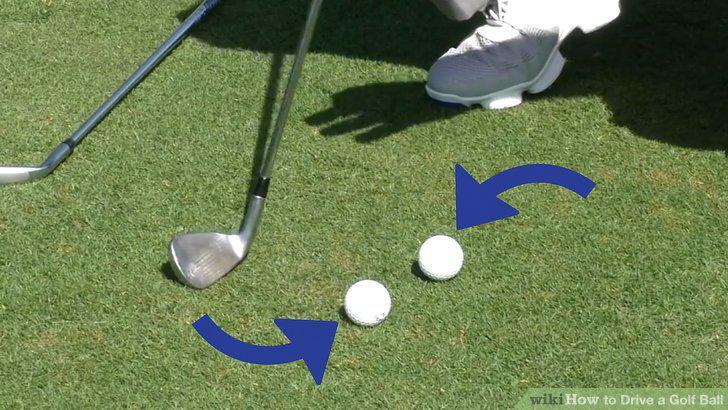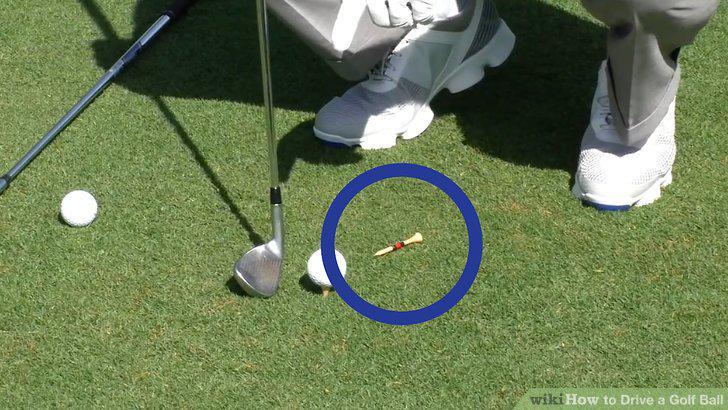The first image is the image on the left, the second image is the image on the right. Given the left and right images, does the statement "The number 1 is on exactly one of the balls." hold true? Answer yes or no. No. 